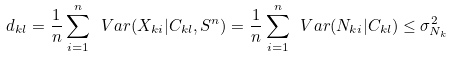Convert formula to latex. <formula><loc_0><loc_0><loc_500><loc_500>d _ { k l } = \frac { 1 } { n } \sum _ { i = 1 } ^ { n } \ V a r ( X _ { k i } | C _ { k l } , S ^ { n } ) = \frac { 1 } { n } \sum _ { i = 1 } ^ { n } \ V a r ( N _ { k i } | C _ { k l } ) \leq \sigma _ { N _ { k } } ^ { 2 }</formula> 